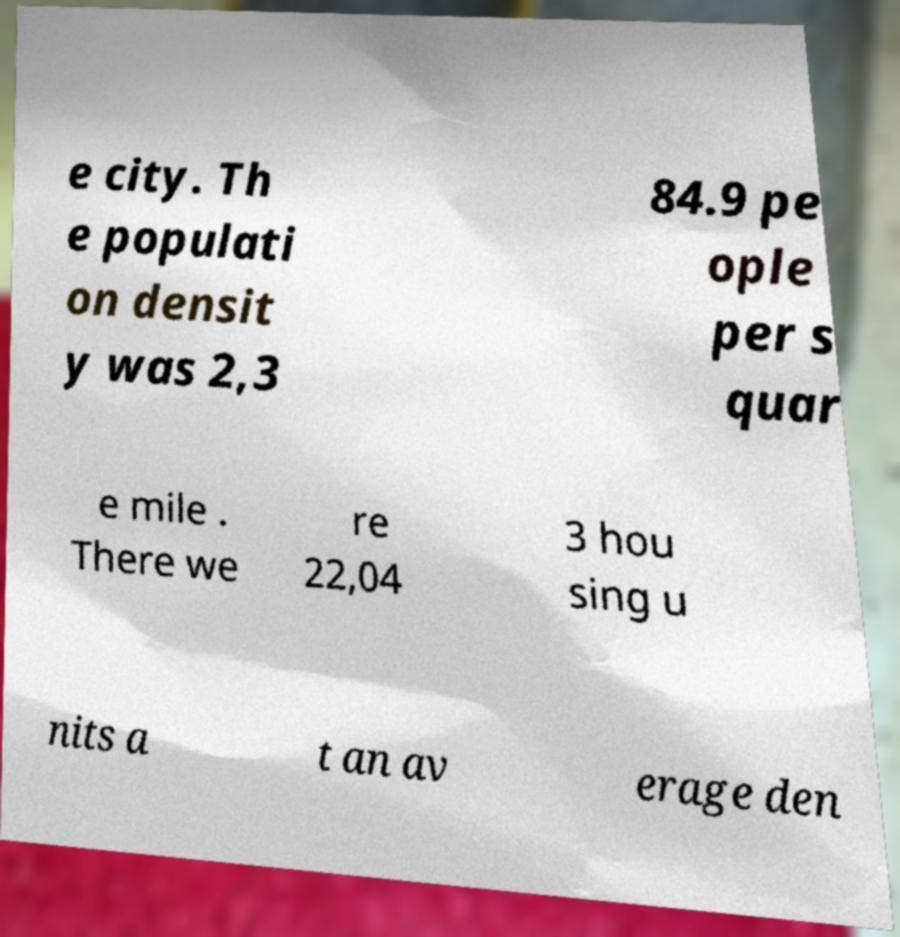Please identify and transcribe the text found in this image. e city. Th e populati on densit y was 2,3 84.9 pe ople per s quar e mile . There we re 22,04 3 hou sing u nits a t an av erage den 